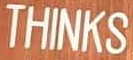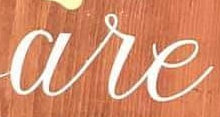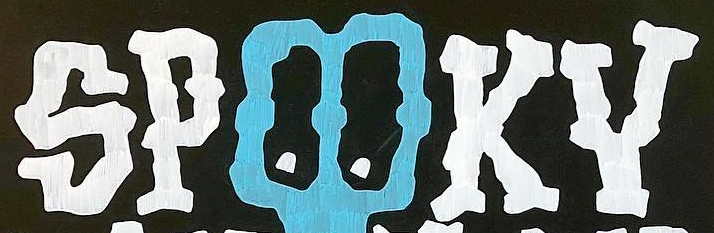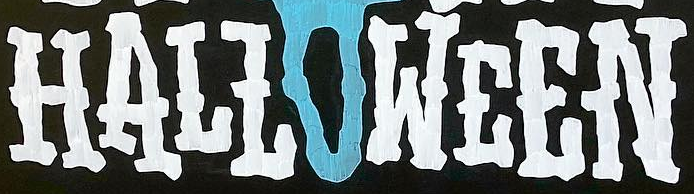Transcribe the words shown in these images in order, separated by a semicolon. THINKS; are; SPOOKY; HALLOWEEN 